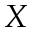Convert formula to latex. <formula><loc_0><loc_0><loc_500><loc_500>X</formula> 